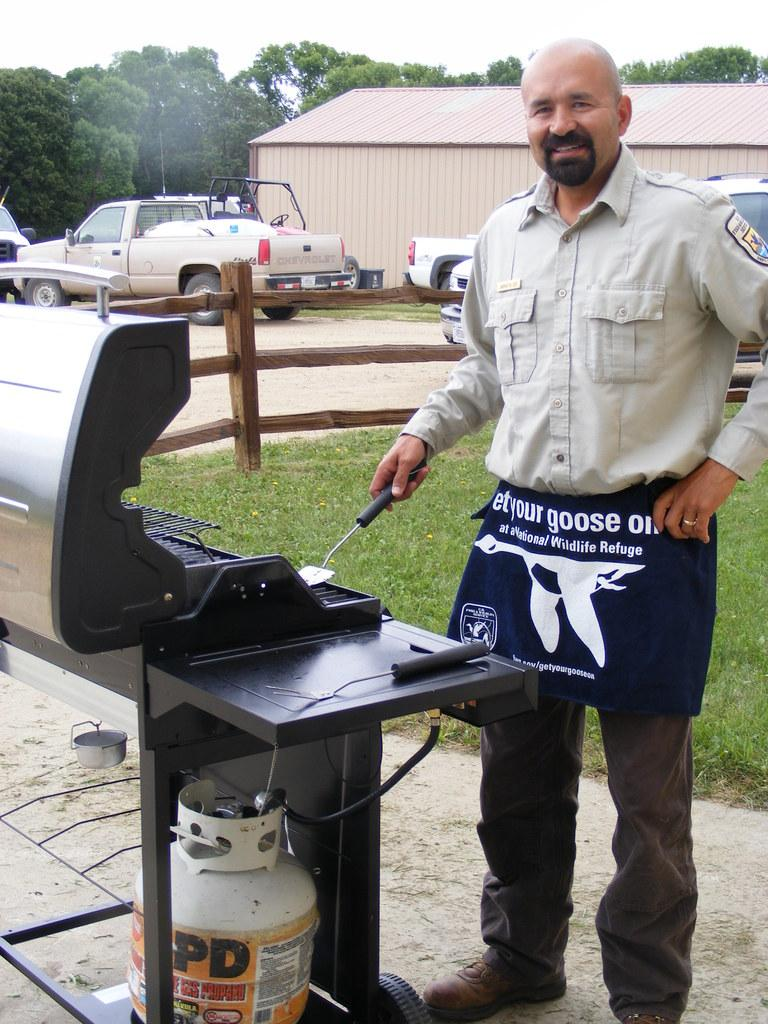Provide a one-sentence caption for the provided image. A man standing at the grill wears an apron stating "Let your goose out". 